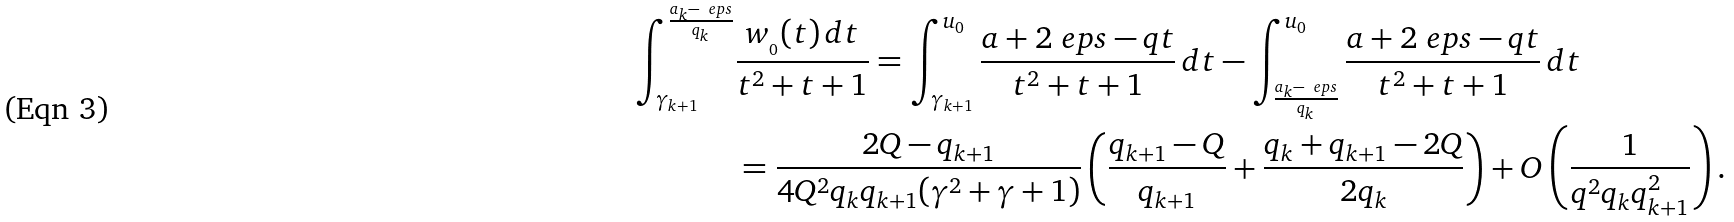Convert formula to latex. <formula><loc_0><loc_0><loc_500><loc_500>\int _ { \gamma _ { k + 1 } } ^ { \frac { a _ { k } - \ e p s } { q _ { k } } } & \frac { w _ { \AA _ { 0 } } ( t ) \, d t } { t ^ { 2 } + t + 1 } = \int _ { \gamma _ { k + 1 } } ^ { u _ { 0 } } \frac { a + 2 \ e p s - q t } { t ^ { 2 } + t + 1 } \, d t - \int _ { \frac { a _ { k } - \ e p s } { q _ { k } } } ^ { u _ { 0 } } \frac { a + 2 \ e p s - q t } { t ^ { 2 } + t + 1 } \, d t \\ & = \frac { 2 Q - q _ { k + 1 } } { 4 Q ^ { 2 } q _ { k } q _ { k + 1 } ( \gamma ^ { 2 } + \gamma + 1 ) } \left ( \frac { q _ { k + 1 } - Q } { q _ { k + 1 } } + \frac { q _ { k } + q _ { k + 1 } - 2 Q } { 2 q _ { k } } \right ) + O \left ( \frac { 1 } { q ^ { 2 } q _ { k } q _ { k + 1 } ^ { 2 } } \right ) .</formula> 